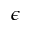<formula> <loc_0><loc_0><loc_500><loc_500>\epsilon</formula> 